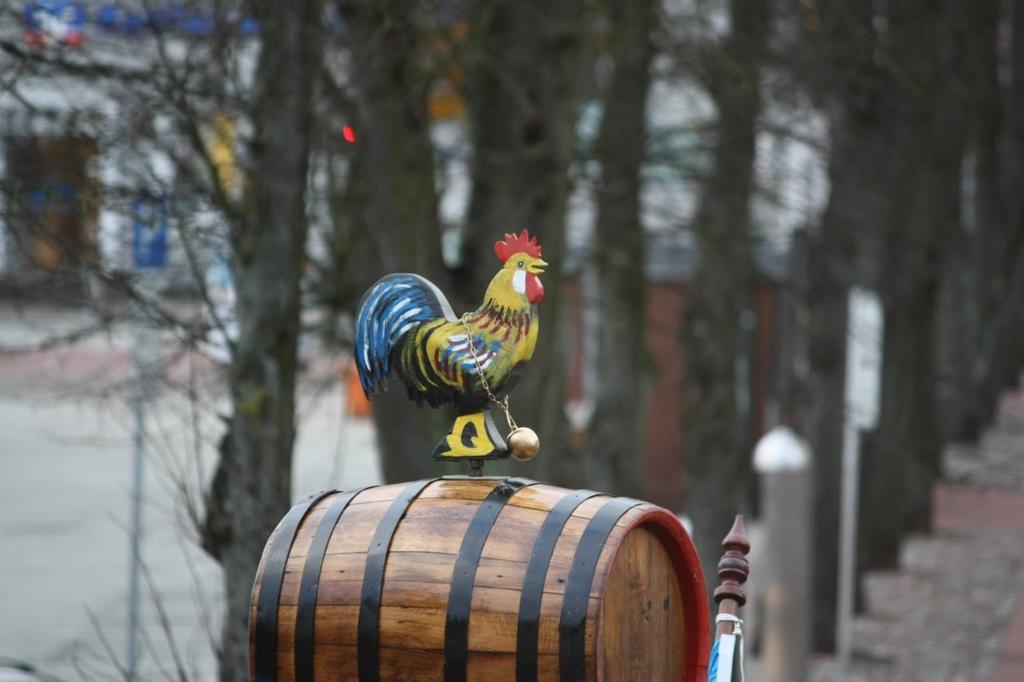What musical instrument is present in the image? There is a drum in the image. What type of animal is depicted as a statue in the image? There is a statue of a hen in the image. How would you describe the background of the image? The background of the image is blurred. What type of vegetation can be seen in the image? Trees are visible in the image. What color is the scarf wrapped around the drum in the image? There is no scarf wrapped around the drum in the image. What type of pleasure can be seen being experienced by the statue of the hen in the image? The statue of the hen is not experiencing any pleasure, as it is an inanimate object. 